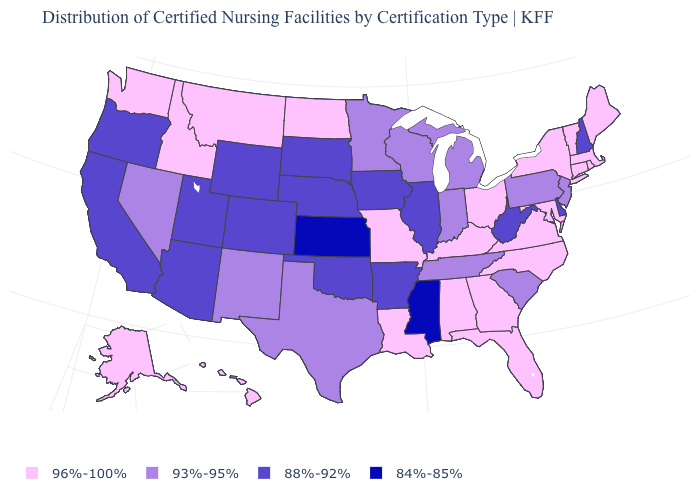Among the states that border Connecticut , which have the highest value?
Quick response, please. Massachusetts, New York, Rhode Island. What is the value of Nebraska?
Concise answer only. 88%-92%. Name the states that have a value in the range 84%-85%?
Give a very brief answer. Kansas, Mississippi. Is the legend a continuous bar?
Quick response, please. No. Name the states that have a value in the range 96%-100%?
Short answer required. Alabama, Alaska, Connecticut, Florida, Georgia, Hawaii, Idaho, Kentucky, Louisiana, Maine, Maryland, Massachusetts, Missouri, Montana, New York, North Carolina, North Dakota, Ohio, Rhode Island, Vermont, Virginia, Washington. Name the states that have a value in the range 93%-95%?
Keep it brief. Indiana, Michigan, Minnesota, Nevada, New Jersey, New Mexico, Pennsylvania, South Carolina, Tennessee, Texas, Wisconsin. Does West Virginia have a higher value than Pennsylvania?
Keep it brief. No. Does West Virginia have the lowest value in the USA?
Give a very brief answer. No. Which states hav the highest value in the MidWest?
Short answer required. Missouri, North Dakota, Ohio. What is the value of Florida?
Quick response, please. 96%-100%. What is the value of New Jersey?
Write a very short answer. 93%-95%. What is the highest value in states that border Nebraska?
Concise answer only. 96%-100%. What is the value of Arkansas?
Keep it brief. 88%-92%. Does the map have missing data?
Short answer required. No. Name the states that have a value in the range 88%-92%?
Short answer required. Arizona, Arkansas, California, Colorado, Delaware, Illinois, Iowa, Nebraska, New Hampshire, Oklahoma, Oregon, South Dakota, Utah, West Virginia, Wyoming. 